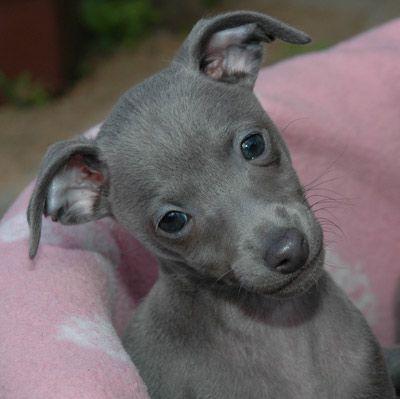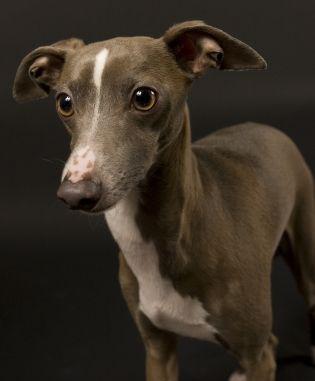The first image is the image on the left, the second image is the image on the right. Evaluate the accuracy of this statement regarding the images: "The right image contains at least one dog wearing a collar.". Is it true? Answer yes or no. No. The first image is the image on the left, the second image is the image on the right. Given the left and right images, does the statement "At least one dog in the image on the right is wearing a collar." hold true? Answer yes or no. No. 